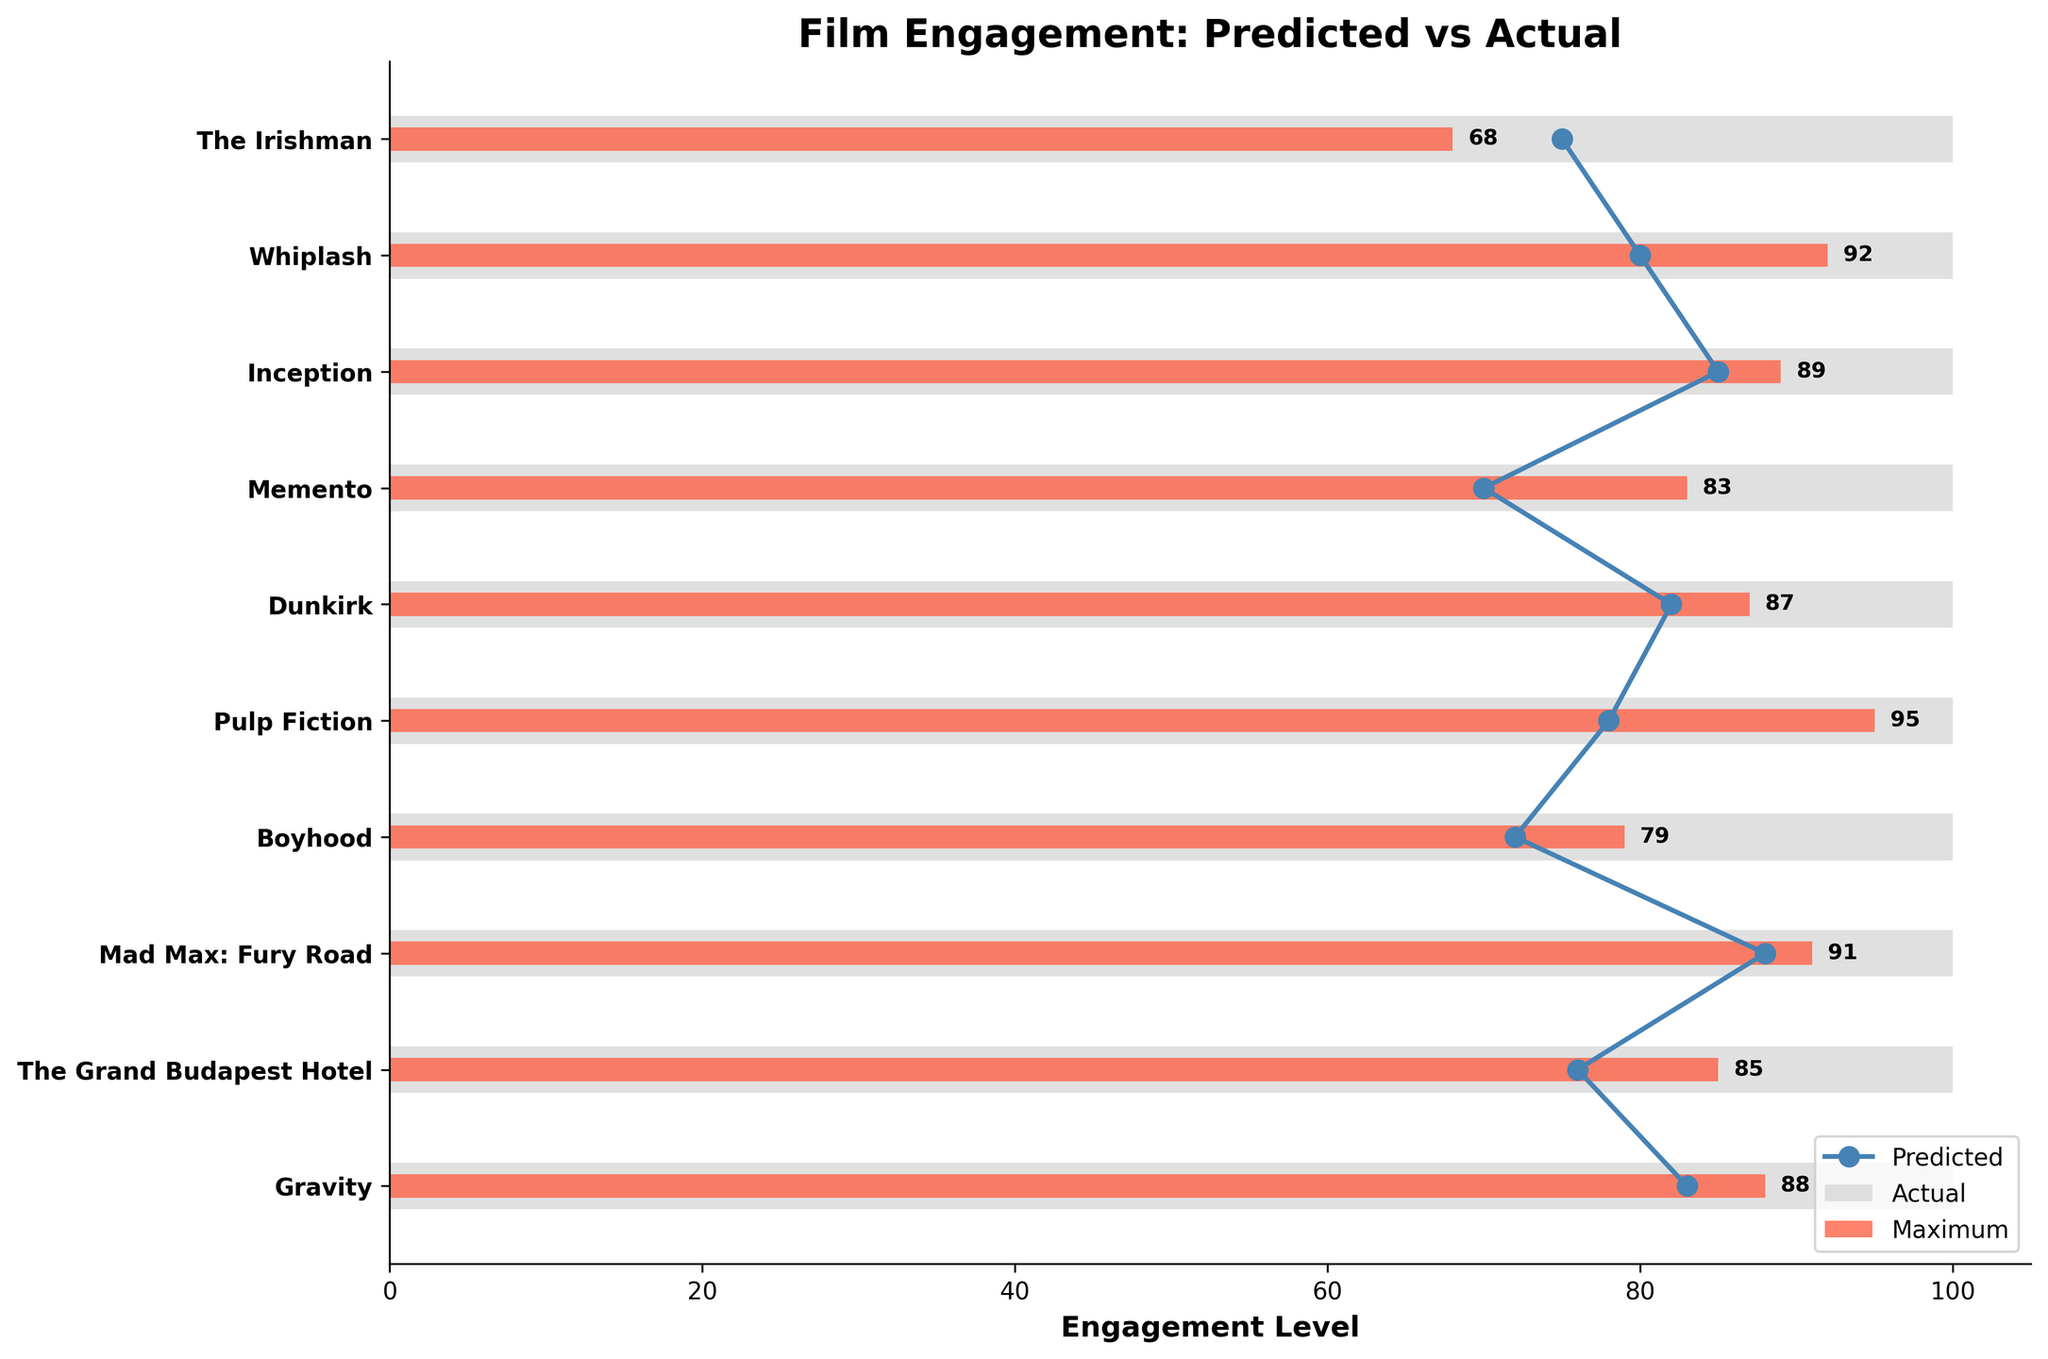What's the title of the figure? The title of the figure is displayed prominently at the top.
Answer: Film Engagement: Predicted vs Actual How many films are compared in the figure? The number of films can be counted by looking at the y-axis labels. There are 10 labels.
Answer: 10 Which film has the largest difference between predicted and actual engagement levels? By visually inspecting the lines and bars, compare the values for each film. Pulp Fiction has the largest difference with a predicted value of 78 and an actual value of 95, making the difference 17.
Answer: Pulp Fiction What's the average actual engagement level of all films? Add all the actual engagement levels (68 + 92 + 89 + 83 + 87 + 95 + 79 + 91 + 85 + 88) = 857, then divide by the number of films (10). 857 / 10 = 85.7.
Answer: 85.7 Which film meets its predicted engagement level most closely? Compare the differences for each film visually. The Grand Budapest Hotel has the closest match with predicted 76 and actual 85.
Answer: The Grand Budapest Hotel How many films have an actual engagement level higher than their predicted engagement level? Count the films where the red bar extends beyond the blue line. The films are Whiplash, Inception, Memento, Dunkirk, Pulp Fiction, The Grand Budapest Hotel, and Gravity. There are 7 such films.
Answer: 7 What is the difference in actual engagement levels between The Irishman and Mad Max: Fury Road? Subtract The Irishman's actual engagement (68) from Mad Max: Fury Road's actual engagement (91). 91 - 68 = 23.
Answer: 23 Which film has the highest predicted engagement level? The tallest blue line indicates the highest predicted level. Inception has the highest predicted engagement of 85.
Answer: Inception Which films have an actual engagement level above 90? Look for red bars that extend beyond the 90 mark on the x-axis. Whiplash, Pulp Fiction, and Mad Max: Fury Road all have actual engagement levels above 90.
Answer: Whiplash, Pulp Fiction, Mad Max: Fury Road 